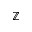Convert formula to latex. <formula><loc_0><loc_0><loc_500><loc_500>\mathbb { Z }</formula> 